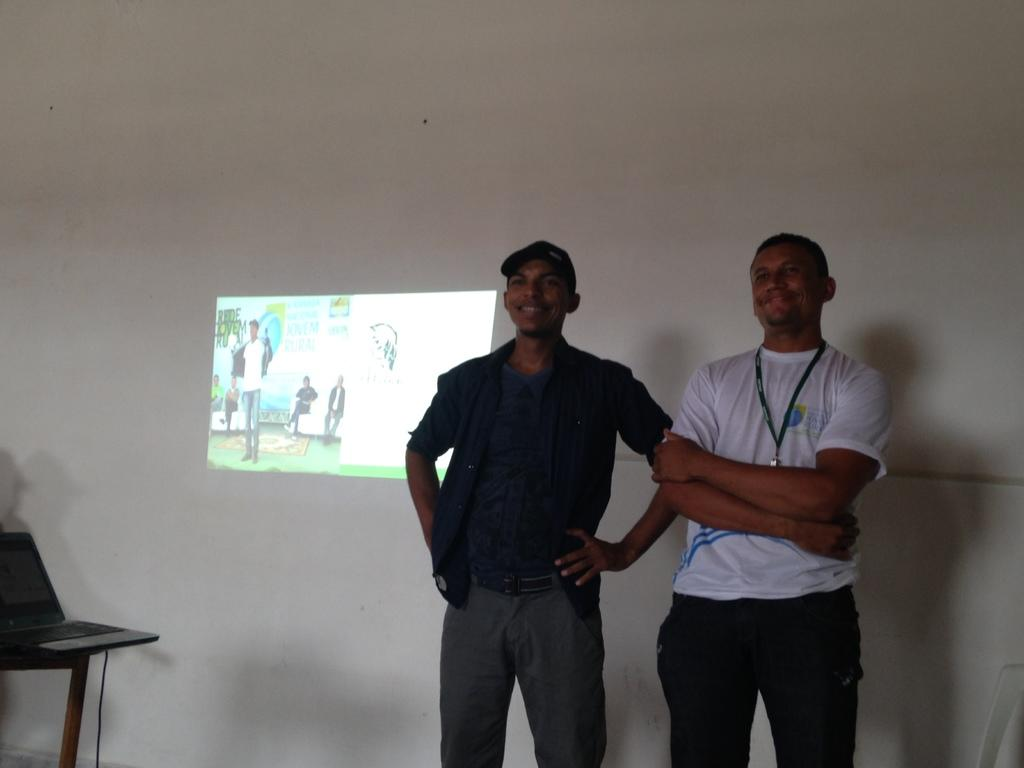How many people are in the image? There are two persons in the image. What can be seen in the background of the image? There is a white wall in the image. What object is on the table in the image? There is a laptop on a table in the image. What is connected to the laptop in the image? There is a wire visible in the image, which is likely connected to the laptop. What color are the eyes of the person on the left in the image? There is no information about the color of the eyes of the person on the left in the image. --- 